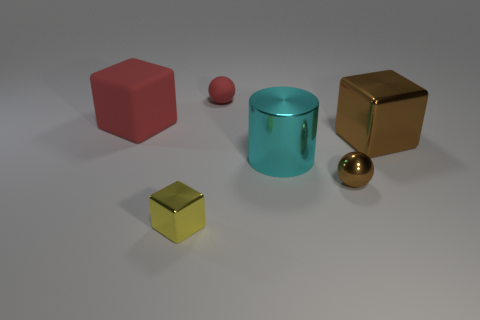Is there any other thing that has the same color as the big shiny cylinder?
Keep it short and to the point. No. What color is the small matte thing that is the same shape as the small brown metal thing?
Make the answer very short. Red. There is a object that is both behind the cyan object and on the right side of the small rubber object; how big is it?
Ensure brevity in your answer.  Large. Is the shape of the red rubber object left of the tiny yellow metallic block the same as the small object left of the red ball?
Provide a succinct answer. Yes. What shape is the thing that is the same color as the small rubber ball?
Ensure brevity in your answer.  Cube. How many big brown blocks are the same material as the cyan cylinder?
Give a very brief answer. 1. What shape is the thing that is both in front of the big metal cube and on the left side of the tiny red rubber object?
Offer a very short reply. Cube. Does the large red object that is behind the metallic ball have the same material as the small red object?
Your response must be concise. Yes. Is there anything else that has the same material as the tiny cube?
Offer a terse response. Yes. There is a rubber object that is the same size as the cyan cylinder; what color is it?
Your answer should be very brief. Red. 